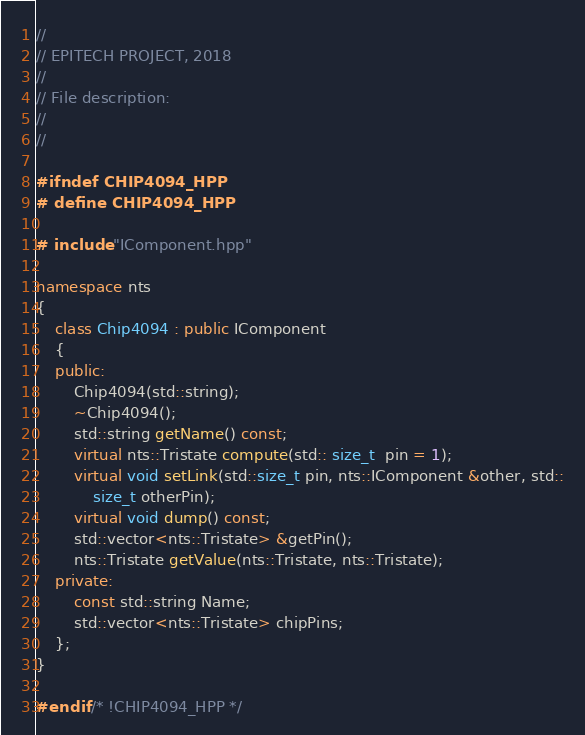<code> <loc_0><loc_0><loc_500><loc_500><_C++_>//
// EPITECH PROJECT, 2018
//
// File description:
//
//

#ifndef CHIP4094_HPP
# define CHIP4094_HPP

# include "IComponent.hpp"

namespace nts
{
	class Chip4094 : public IComponent
	{
	public:
		Chip4094(std::string);
		~Chip4094();
		std::string getName() const;
		virtual nts::Tristate compute(std:: size_t  pin = 1);
		virtual void setLink(std::size_t pin, nts::IComponent &other, std::
			size_t otherPin);
		virtual void dump() const;
		std::vector<nts::Tristate> &getPin();
		nts::Tristate getValue(nts::Tristate, nts::Tristate);
	private:
		const std::string Name;
		std::vector<nts::Tristate> chipPins;
	};
}

#endif /* !CHIP4094_HPP */
</code> 